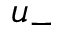<formula> <loc_0><loc_0><loc_500><loc_500>u _ { - }</formula> 